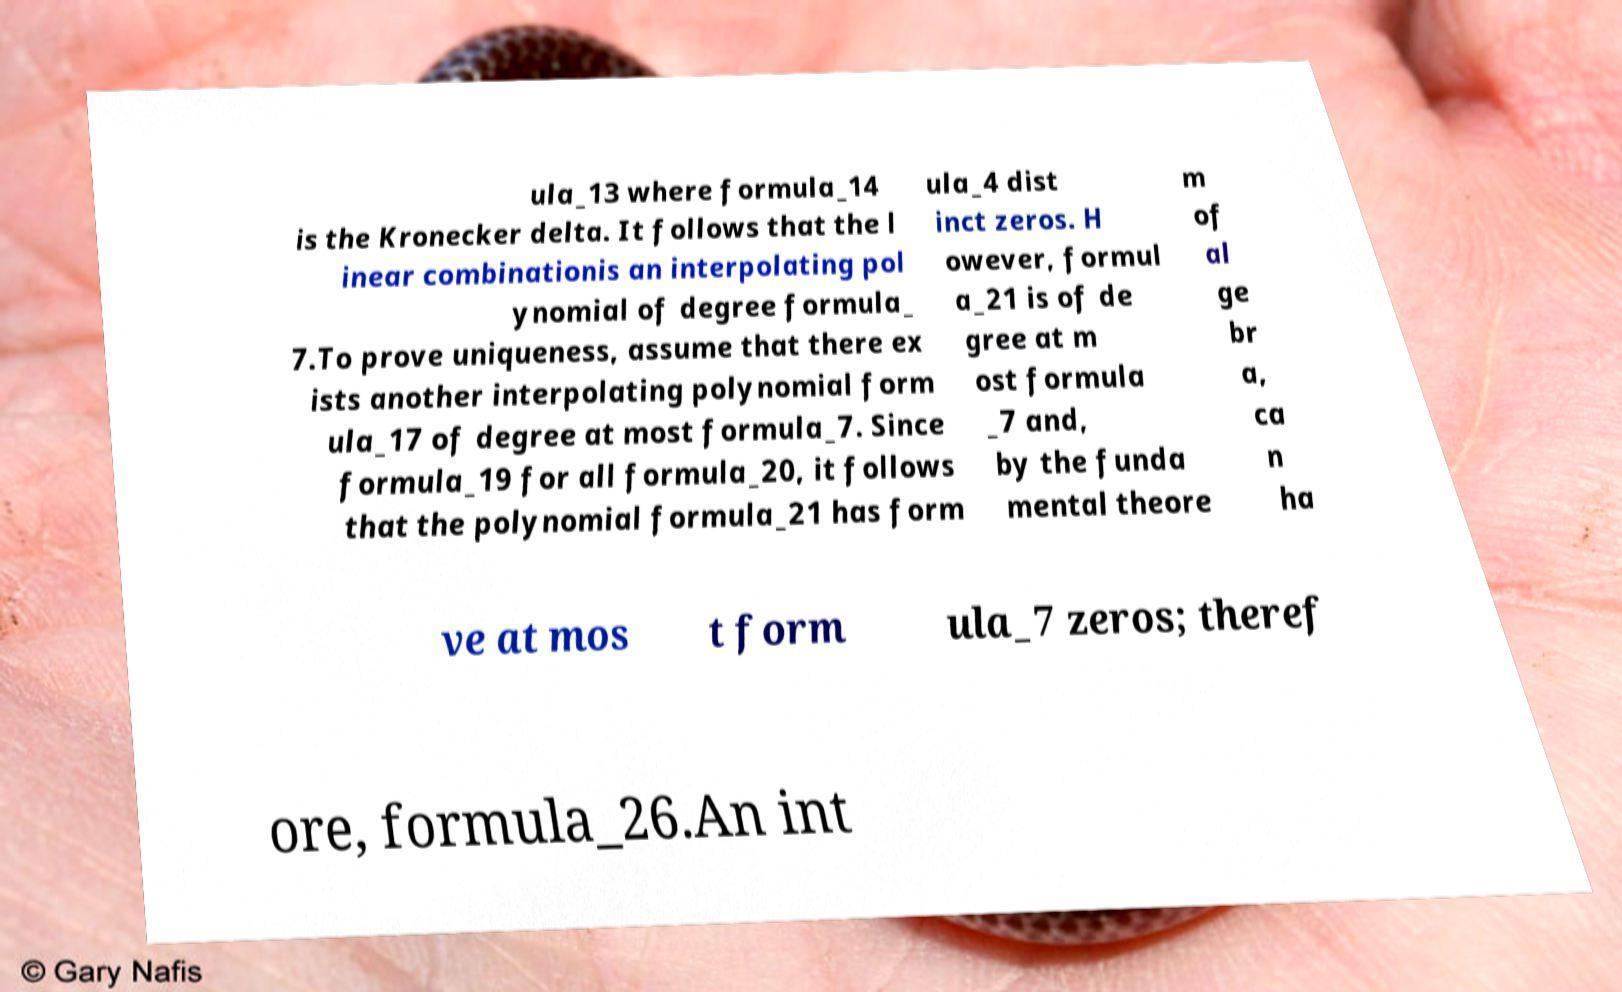Please read and relay the text visible in this image. What does it say? ula_13 where formula_14 is the Kronecker delta. It follows that the l inear combinationis an interpolating pol ynomial of degree formula_ 7.To prove uniqueness, assume that there ex ists another interpolating polynomial form ula_17 of degree at most formula_7. Since formula_19 for all formula_20, it follows that the polynomial formula_21 has form ula_4 dist inct zeros. H owever, formul a_21 is of de gree at m ost formula _7 and, by the funda mental theore m of al ge br a, ca n ha ve at mos t form ula_7 zeros; theref ore, formula_26.An int 